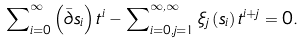Convert formula to latex. <formula><loc_0><loc_0><loc_500><loc_500>\sum \nolimits _ { i = 0 } ^ { \infty } \left ( \bar { \partial } s _ { i } \right ) t ^ { i } - \sum \nolimits _ { i = 0 , j = 1 } ^ { \infty , \infty } \xi _ { j } \left ( s _ { i } \right ) t ^ { i + j } = 0 .</formula> 